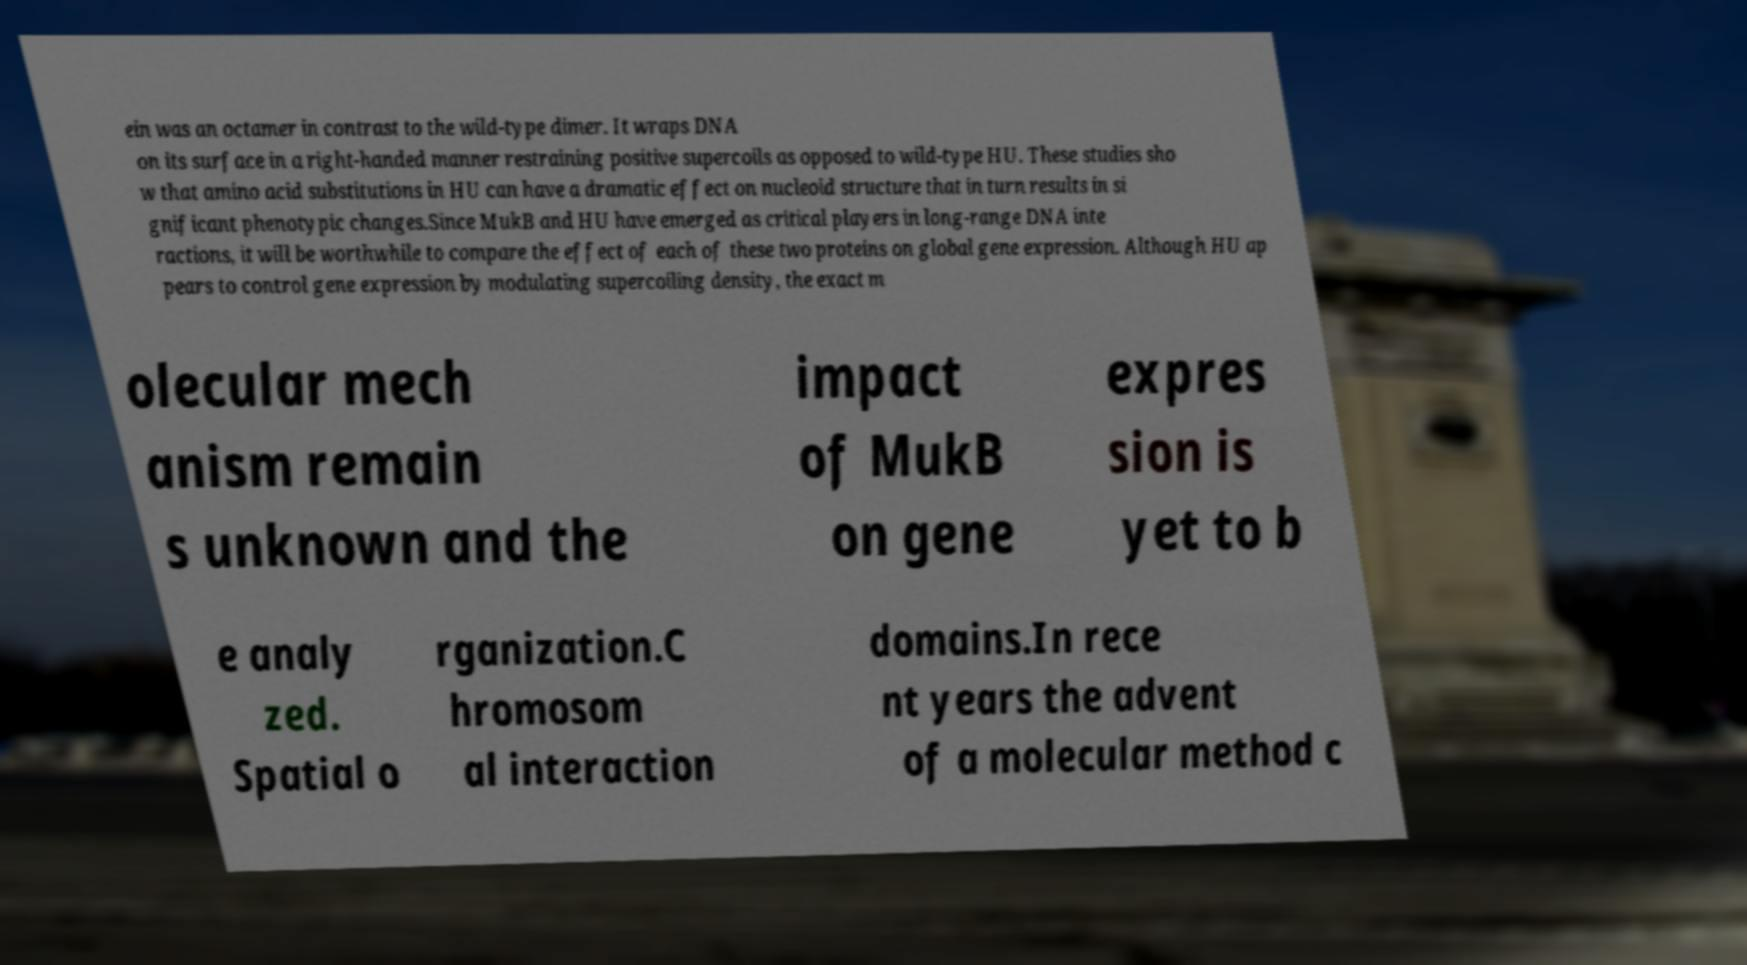For documentation purposes, I need the text within this image transcribed. Could you provide that? ein was an octamer in contrast to the wild-type dimer. It wraps DNA on its surface in a right-handed manner restraining positive supercoils as opposed to wild-type HU. These studies sho w that amino acid substitutions in HU can have a dramatic effect on nucleoid structure that in turn results in si gnificant phenotypic changes.Since MukB and HU have emerged as critical players in long-range DNA inte ractions, it will be worthwhile to compare the effect of each of these two proteins on global gene expression. Although HU ap pears to control gene expression by modulating supercoiling density, the exact m olecular mech anism remain s unknown and the impact of MukB on gene expres sion is yet to b e analy zed. Spatial o rganization.C hromosom al interaction domains.In rece nt years the advent of a molecular method c 